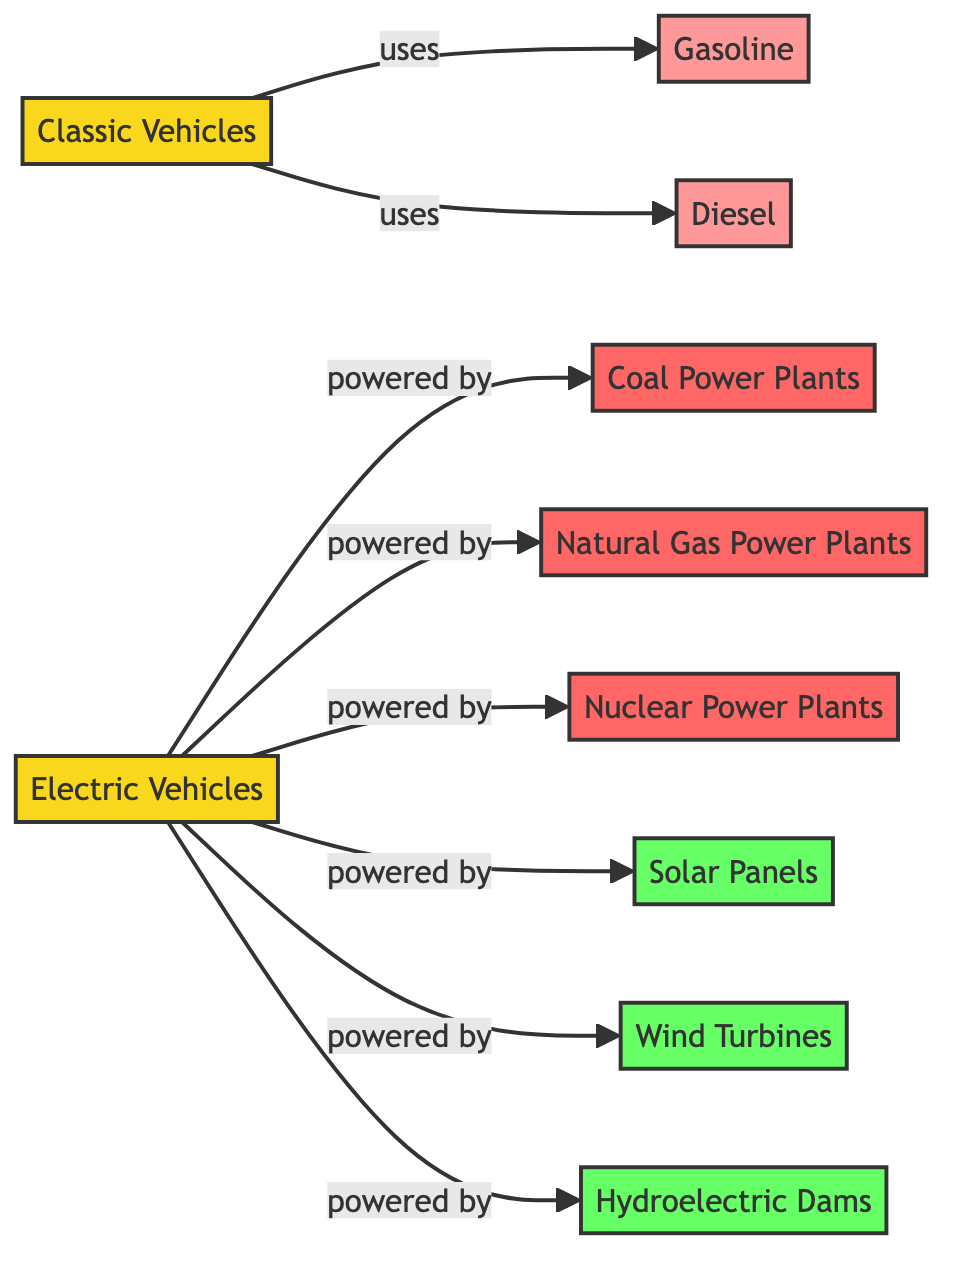What are the two types of vehicles depicted in the diagram? The diagram includes two vehicle types: Classic Vehicles and Electric Vehicles. This information is found in the nodes where these vehicles are identified.
Answer: Classic Vehicles, Electric Vehicles How many fuel sources are associated with classic vehicles? Classic vehicles are linked to two fuel sources: Gasoline and Diesel. This can be observed in the edges connecting classic vehicles to these fuel sources in the diagram.
Answer: 2 What is the primary renewable energy source shown for electric vehicles? The diagram shows three renewable energy sources for electric vehicles: Solar Panels, Wind Turbines, and Hydroelectric Dams. While all are renewable, if focusing on one, Solar Panels is a significant example.
Answer: Solar Panels Which non-renewable energy source is not related to electric vehicles? The diagram outlines several energy sources for electric vehicles, including Coal Power Plants, Natural Gas Power Plants, and Nuclear Power Plants. It does not connect to Diesel, which is related to classic vehicles.
Answer: Diesel How many total nodes are in the diagram? In the diagram, there are ten nodes visible: two vehicle types and eight energy sources, totaling ten distinct nodes. Counting each type confirms this total.
Answer: 10 What connects electric vehicles to renewable energy sources? The diagram indicates that electric vehicles are powered by three renewable energy sources: Solar Panels, Wind Turbines, and Hydroelectric Dams. The connections (edges) from electric vehicles to these nodes illustrate this relationship.
Answer: Solar Panels, Wind Turbines, Hydroelectric Dams Which energy source has the strongest link to electric vehicles? The diagram shows that electric vehicles are powered by several energy sources. Since all connections represent similar relationships, it’s reasonable to conclude that each non-renewable source could be seen as equally impactful based solely on presence. However, if one had to choose, Nuclear Power Plants often provides reliable energy.
Answer: Nuclear Power Plants What type of connection is used to link classic vehicles with their fuel source? The edges that link classic vehicles to their fuel sources (Gasoline and Diesel) use "uses" as the connecting label in the diagram. This label illustrates the relationship of consumption.
Answer: uses How many renewable energy sources are depicted in the diagram? The diagram shows three distinct renewable energy sources linked to electric vehicles: Solar Panels, Wind Turbines, and Hydroelectric Dams. Counting these confirms the number is three.
Answer: 3 